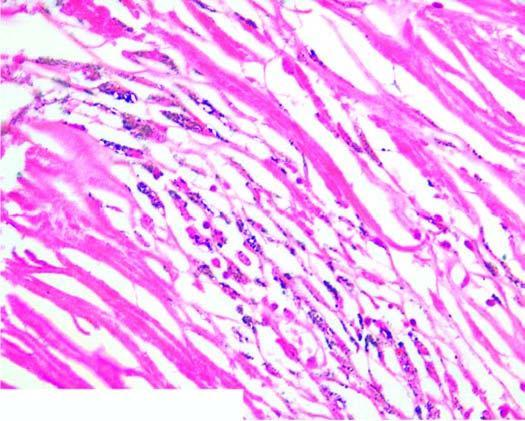what does the silicotic nodule consist of?
Answer the question using a single word or phrase. Hyaline centre surrounded by concentric layers of collagen 